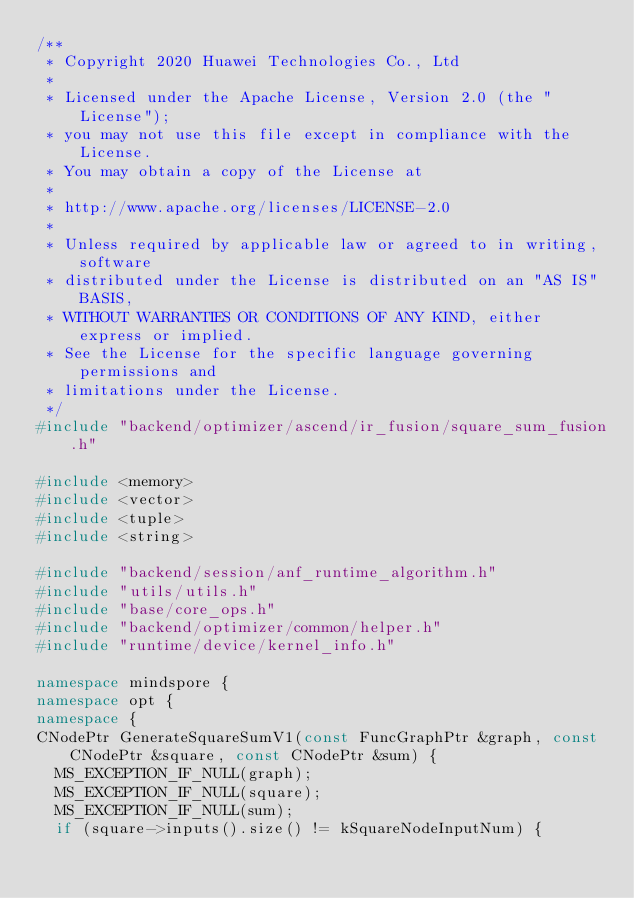<code> <loc_0><loc_0><loc_500><loc_500><_C++_>/**
 * Copyright 2020 Huawei Technologies Co., Ltd
 *
 * Licensed under the Apache License, Version 2.0 (the "License");
 * you may not use this file except in compliance with the License.
 * You may obtain a copy of the License at
 *
 * http://www.apache.org/licenses/LICENSE-2.0
 *
 * Unless required by applicable law or agreed to in writing, software
 * distributed under the License is distributed on an "AS IS" BASIS,
 * WITHOUT WARRANTIES OR CONDITIONS OF ANY KIND, either express or implied.
 * See the License for the specific language governing permissions and
 * limitations under the License.
 */
#include "backend/optimizer/ascend/ir_fusion/square_sum_fusion.h"

#include <memory>
#include <vector>
#include <tuple>
#include <string>

#include "backend/session/anf_runtime_algorithm.h"
#include "utils/utils.h"
#include "base/core_ops.h"
#include "backend/optimizer/common/helper.h"
#include "runtime/device/kernel_info.h"

namespace mindspore {
namespace opt {
namespace {
CNodePtr GenerateSquareSumV1(const FuncGraphPtr &graph, const CNodePtr &square, const CNodePtr &sum) {
  MS_EXCEPTION_IF_NULL(graph);
  MS_EXCEPTION_IF_NULL(square);
  MS_EXCEPTION_IF_NULL(sum);
  if (square->inputs().size() != kSquareNodeInputNum) {</code> 